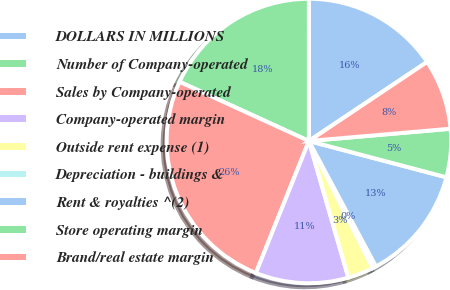<chart> <loc_0><loc_0><loc_500><loc_500><pie_chart><fcel>DOLLARS IN MILLIONS<fcel>Number of Company-operated<fcel>Sales by Company-operated<fcel>Company-operated margin<fcel>Outside rent expense (1)<fcel>Depreciation - buildings &<fcel>Rent & royalties ^(2)<fcel>Store operating margin<fcel>Brand/real estate margin<nl><fcel>15.62%<fcel>18.16%<fcel>25.76%<fcel>10.55%<fcel>2.94%<fcel>0.4%<fcel>13.08%<fcel>5.48%<fcel>8.01%<nl></chart> 